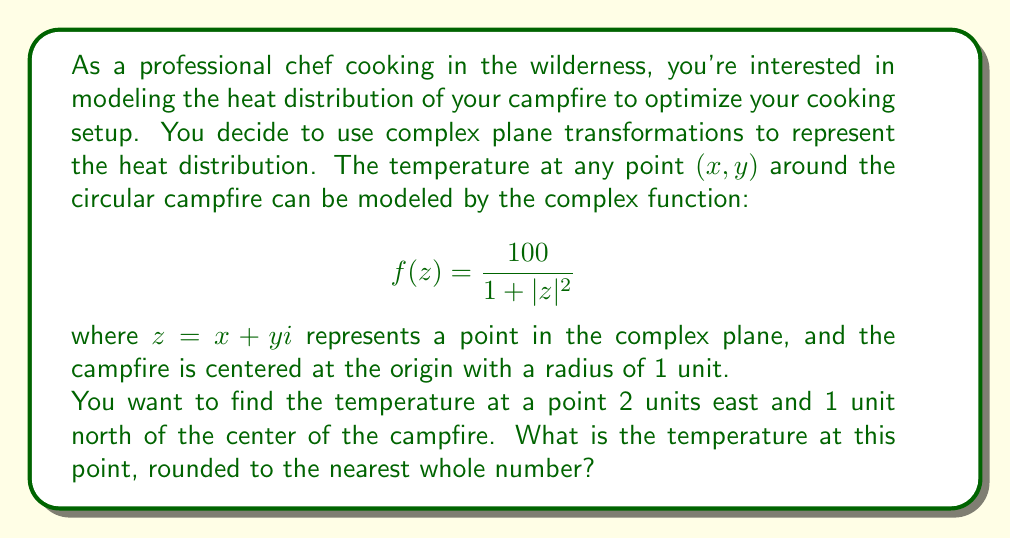Help me with this question. Let's approach this step-by-step:

1) First, we need to identify the complex number $z$ that represents the point 2 units east and 1 unit north of the campfire center. This point has coordinates $(2, 1)$, so:

   $z = 2 + i$

2) Next, we need to calculate $|z|^2$. For a complex number $a + bi$, $|z|^2 = a^2 + b^2$. So:

   $|z|^2 = 2^2 + 1^2 = 4 + 1 = 5$

3) Now we can substitute this into our temperature function:

   $$f(z) = \frac{100}{1 + |z|^2} = \frac{100}{1 + 5} = \frac{100}{6}$$

4) Let's calculate this:

   $\frac{100}{6} \approx 16.6667$

5) Rounding to the nearest whole number:

   $16.6667 \approx 17$

Therefore, the temperature at the point 2 units east and 1 unit north of the campfire center is approximately 17 units (which could represent degrees Celsius or any other temperature unit, depending on how the model is calibrated).
Answer: 17 